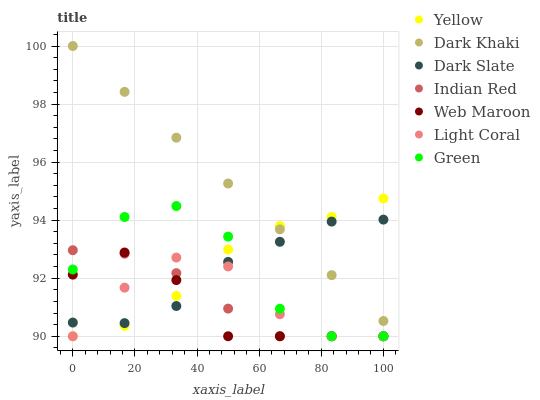Does Web Maroon have the minimum area under the curve?
Answer yes or no. Yes. Does Dark Khaki have the maximum area under the curve?
Answer yes or no. Yes. Does Yellow have the minimum area under the curve?
Answer yes or no. No. Does Yellow have the maximum area under the curve?
Answer yes or no. No. Is Dark Khaki the smoothest?
Answer yes or no. Yes. Is Green the roughest?
Answer yes or no. Yes. Is Web Maroon the smoothest?
Answer yes or no. No. Is Web Maroon the roughest?
Answer yes or no. No. Does Light Coral have the lowest value?
Answer yes or no. Yes. Does Dark Khaki have the lowest value?
Answer yes or no. No. Does Dark Khaki have the highest value?
Answer yes or no. Yes. Does Web Maroon have the highest value?
Answer yes or no. No. Is Indian Red less than Dark Khaki?
Answer yes or no. Yes. Is Dark Khaki greater than Web Maroon?
Answer yes or no. Yes. Does Indian Red intersect Yellow?
Answer yes or no. Yes. Is Indian Red less than Yellow?
Answer yes or no. No. Is Indian Red greater than Yellow?
Answer yes or no. No. Does Indian Red intersect Dark Khaki?
Answer yes or no. No. 